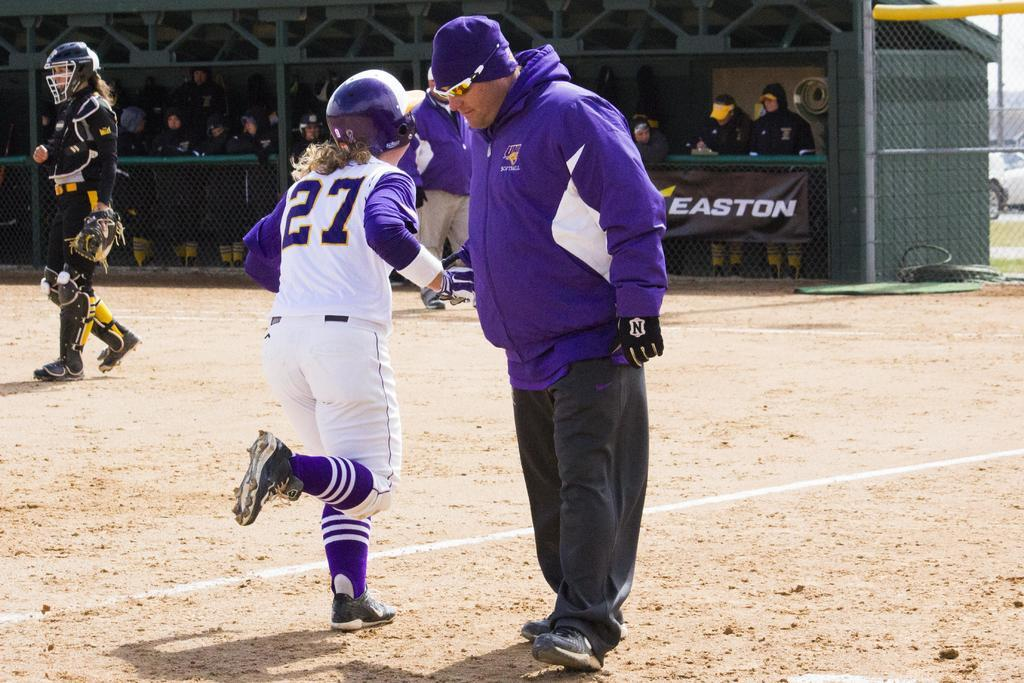<image>
Describe the image concisely. A girl has the number 27 on the back of her jersey. 